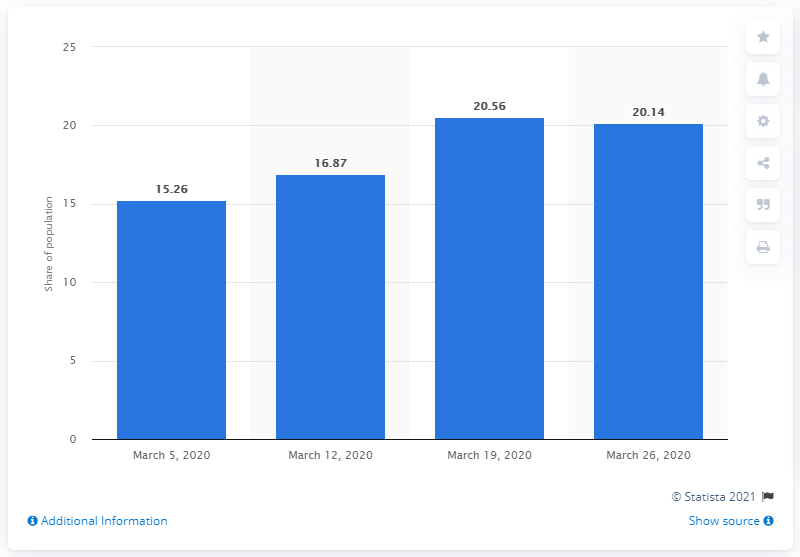Give some essential details in this illustration. In the days leading up to the first confirmed case of COVID-19 in Costa Rica, a significant percentage of the population watched television, according to data released by the Costa Rican Institute of Statistics and Censuses. Specifically, 15.26% of the population viewed television on the day before the first case was reported. On March 26, 2020, 20.14% of Costa Ricans were found to be infected with COVID-19. 